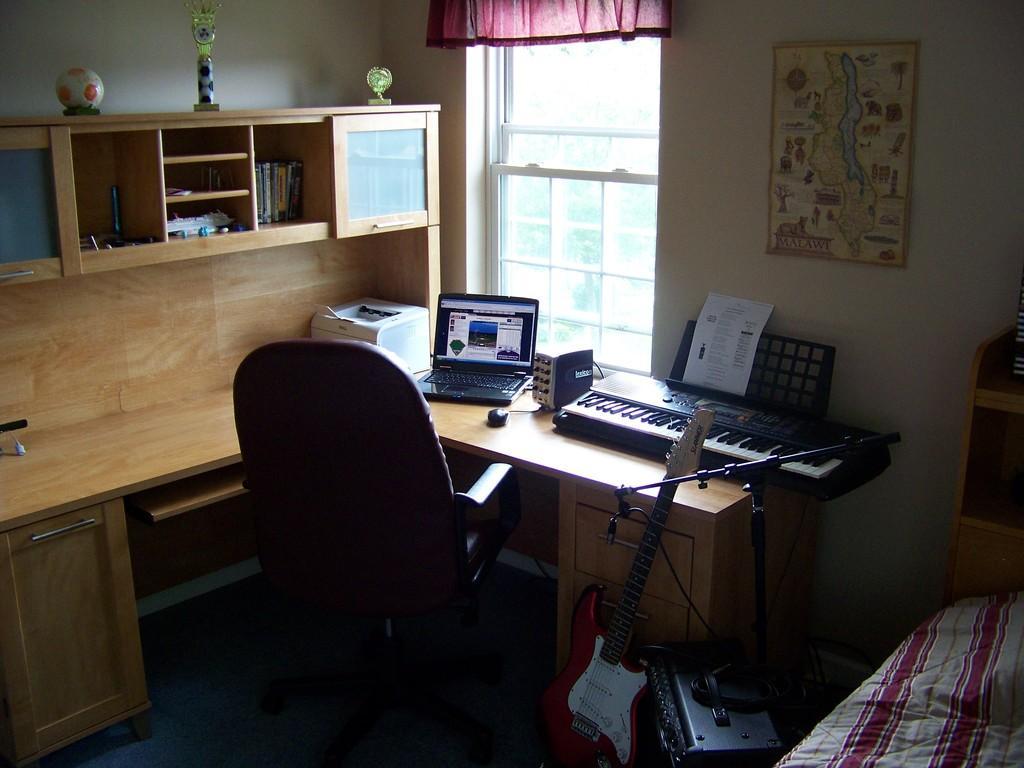Please provide a concise description of this image. This picture is clicked inside the room. On the right corner we can see the bed and there are some objects placed on the ground and we can see a guitar, chair, picture frame hanging on the wall and wooden cabinet containing books, show pieces and some other items and we can see musical keyboard, paper, mouse, laptop and some other items are placed on the top of the wooden table. In the background we can see the curtain and the window. 